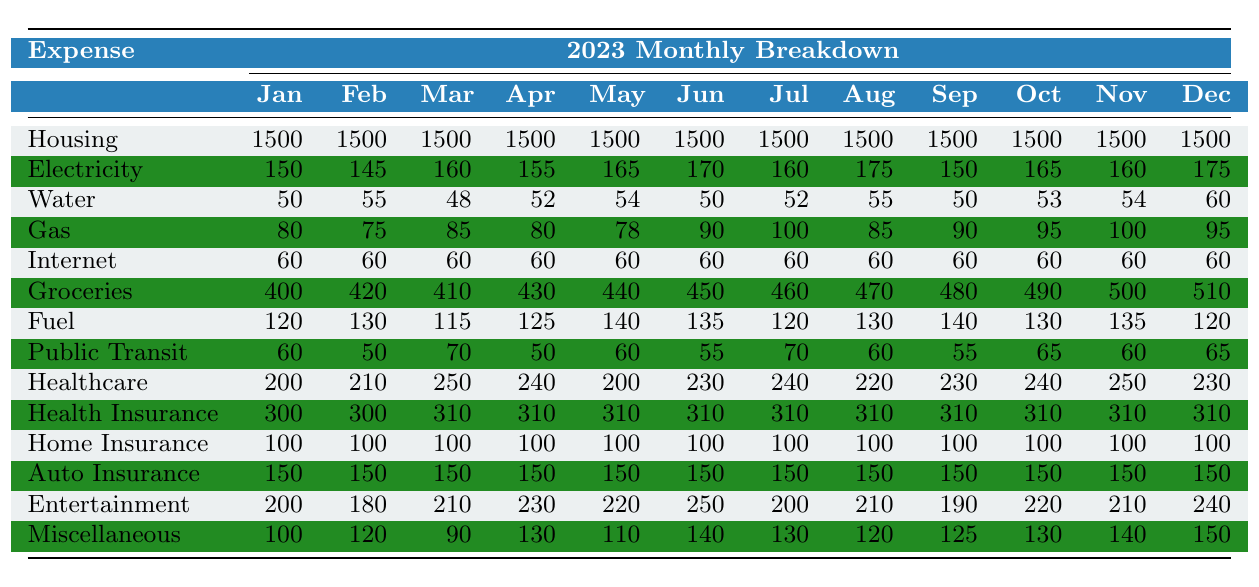What is the highest monthly expense for housing? The housing expense is consistent throughout the year at 1500, as seen in all twelve months. Therefore, the highest monthly expense for housing is simply that amount.
Answer: 1500 In which month are the grocery expenses the highest? The grocery expenses increase month by month, starting from 400 in January and reaching 510 in December. Thus, December has the highest grocery expense.
Answer: December How much did the household spend on utilities in March? For March, the utility expenses are as follows: Electricity (160) + Water (48) + Gas (85) + Internet (60), totaling up to 353.
Answer: 353 What is the average amount spent on healthcare over the year? The healthcare expenses for each month are summed: 200 + 210 + 250 + 240 + 200 + 230 + 240 + 220 + 230 + 240 + 250 + 230 = 2,820. Dividing this by 12 months gives an average of 235.
Answer: 235 Did the entertainment expenses ever fall below 200? By looking at the entertainment values, it's clear that in February, spending dropped to 180. Hence, the statement is true.
Answer: Yes What is the difference in transportation expenses between February and May? The total transportation expenses for February are Fuel (130) + Public Transit (50) = 180, while for May they are Fuel (140) + Public Transit (60) = 200. The difference is 200 - 180 = 20.
Answer: 20 What was the total spending on utilities for the entire year? The total utility expenses across all months can be calculated by summing the individual expenses: (150 + 145 + 160 + 155 + 165 + 170 + 160 + 175 + 150 + 165 + 160 + 175) + (50 + 55 + 48 + 52 + 54 + 50 + 52 + 55 + 50 + 53 + 54 + 60) + (80 + 75 + 85 + 80 + 78 + 90 + 100 + 85 + 90 + 95 + 100 + 95) + (60 + 60 + 60 + 60 + 60 + 60 + 60 + 60 + 60 + 60 + 60 + 60), which equals a total of 1,966.
Answer: 1,966 Which month had the highest miscellaneous expenses? The miscellaneous expenses are checked month by month: 100, 120, 90, 130, 110, 140, 130, 120, 125, 130, 140, 150. December had 150, which is the highest among all months.
Answer: December What is the minimum amount spent on gas during the year? By inspecting the gas expenses per month, we see that the lowest value is 75 in February. Hence, February has the minimum gas expense of that year.
Answer: 75 How much more is spent on healthcare in November compared to January? The healthcare expense in November is 250 and in January, it is 200. Thus, the difference is 250 - 200 = 50.
Answer: 50 